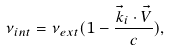<formula> <loc_0><loc_0><loc_500><loc_500>\nu _ { i n t } = \nu _ { e x t } ( 1 - \frac { \vec { k } _ { i } \cdot \vec { V } } { c } ) ,</formula> 